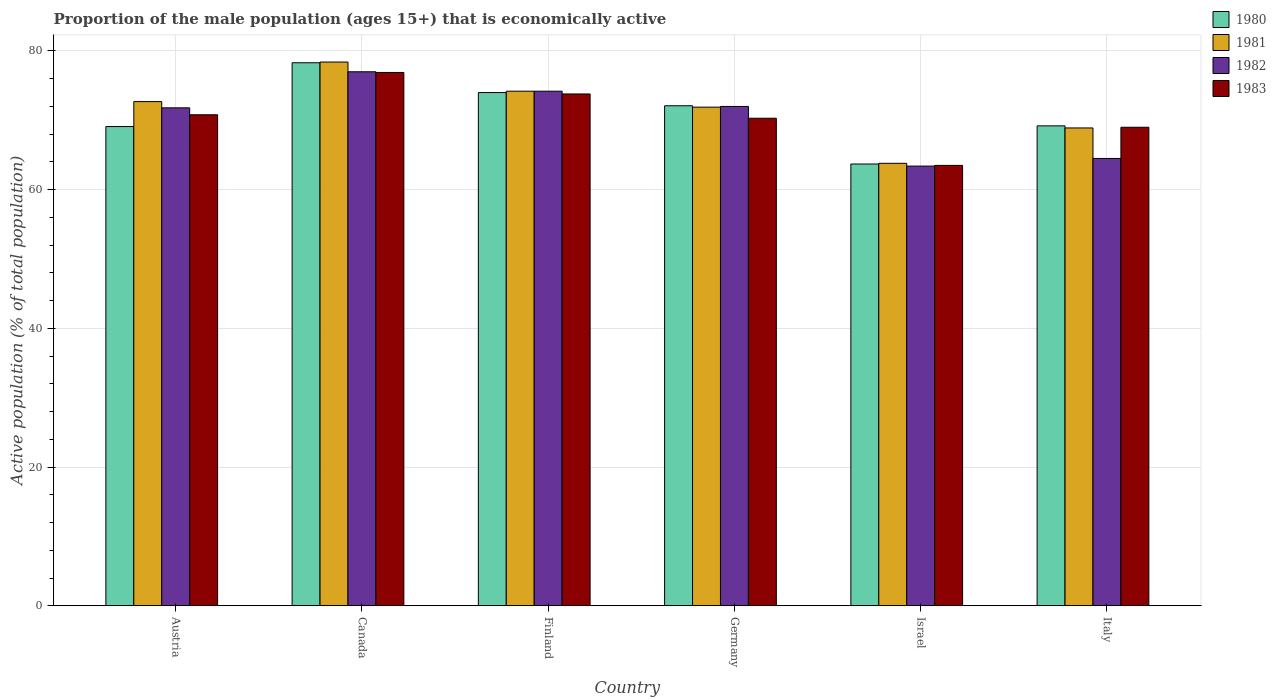How many different coloured bars are there?
Your response must be concise. 4. Are the number of bars on each tick of the X-axis equal?
Provide a succinct answer. Yes. What is the label of the 1st group of bars from the left?
Ensure brevity in your answer.  Austria. What is the proportion of the male population that is economically active in 1982 in Finland?
Keep it short and to the point. 74.2. Across all countries, what is the maximum proportion of the male population that is economically active in 1980?
Offer a very short reply. 78.3. Across all countries, what is the minimum proportion of the male population that is economically active in 1982?
Offer a terse response. 63.4. What is the total proportion of the male population that is economically active in 1982 in the graph?
Make the answer very short. 422.9. What is the difference between the proportion of the male population that is economically active in 1983 in Canada and that in Finland?
Provide a short and direct response. 3.1. What is the difference between the proportion of the male population that is economically active in 1983 in Finland and the proportion of the male population that is economically active in 1980 in Austria?
Keep it short and to the point. 4.7. What is the average proportion of the male population that is economically active in 1983 per country?
Your answer should be very brief. 70.72. What is the difference between the proportion of the male population that is economically active of/in 1983 and proportion of the male population that is economically active of/in 1980 in Austria?
Offer a terse response. 1.7. What is the ratio of the proportion of the male population that is economically active in 1981 in Austria to that in Canada?
Keep it short and to the point. 0.93. What is the difference between the highest and the second highest proportion of the male population that is economically active in 1980?
Offer a very short reply. -1.9. What is the difference between the highest and the lowest proportion of the male population that is economically active in 1981?
Ensure brevity in your answer.  14.6. In how many countries, is the proportion of the male population that is economically active in 1980 greater than the average proportion of the male population that is economically active in 1980 taken over all countries?
Your response must be concise. 3. What does the 2nd bar from the left in Canada represents?
Provide a short and direct response. 1981. Are all the bars in the graph horizontal?
Offer a terse response. No. Are the values on the major ticks of Y-axis written in scientific E-notation?
Keep it short and to the point. No. Does the graph contain any zero values?
Offer a very short reply. No. Where does the legend appear in the graph?
Make the answer very short. Top right. How are the legend labels stacked?
Offer a terse response. Vertical. What is the title of the graph?
Provide a succinct answer. Proportion of the male population (ages 15+) that is economically active. Does "1986" appear as one of the legend labels in the graph?
Your response must be concise. No. What is the label or title of the Y-axis?
Give a very brief answer. Active population (% of total population). What is the Active population (% of total population) in 1980 in Austria?
Make the answer very short. 69.1. What is the Active population (% of total population) of 1981 in Austria?
Make the answer very short. 72.7. What is the Active population (% of total population) in 1982 in Austria?
Your response must be concise. 71.8. What is the Active population (% of total population) of 1983 in Austria?
Keep it short and to the point. 70.8. What is the Active population (% of total population) in 1980 in Canada?
Provide a succinct answer. 78.3. What is the Active population (% of total population) of 1981 in Canada?
Your answer should be compact. 78.4. What is the Active population (% of total population) in 1982 in Canada?
Your response must be concise. 77. What is the Active population (% of total population) in 1983 in Canada?
Offer a terse response. 76.9. What is the Active population (% of total population) of 1980 in Finland?
Provide a succinct answer. 74. What is the Active population (% of total population) of 1981 in Finland?
Your answer should be very brief. 74.2. What is the Active population (% of total population) in 1982 in Finland?
Offer a very short reply. 74.2. What is the Active population (% of total population) in 1983 in Finland?
Provide a short and direct response. 73.8. What is the Active population (% of total population) in 1980 in Germany?
Give a very brief answer. 72.1. What is the Active population (% of total population) in 1981 in Germany?
Offer a very short reply. 71.9. What is the Active population (% of total population) of 1982 in Germany?
Give a very brief answer. 72. What is the Active population (% of total population) in 1983 in Germany?
Offer a terse response. 70.3. What is the Active population (% of total population) of 1980 in Israel?
Your answer should be compact. 63.7. What is the Active population (% of total population) in 1981 in Israel?
Offer a terse response. 63.8. What is the Active population (% of total population) in 1982 in Israel?
Offer a very short reply. 63.4. What is the Active population (% of total population) in 1983 in Israel?
Keep it short and to the point. 63.5. What is the Active population (% of total population) of 1980 in Italy?
Provide a succinct answer. 69.2. What is the Active population (% of total population) in 1981 in Italy?
Your answer should be very brief. 68.9. What is the Active population (% of total population) of 1982 in Italy?
Provide a succinct answer. 64.5. What is the Active population (% of total population) in 1983 in Italy?
Give a very brief answer. 69. Across all countries, what is the maximum Active population (% of total population) in 1980?
Offer a very short reply. 78.3. Across all countries, what is the maximum Active population (% of total population) in 1981?
Your response must be concise. 78.4. Across all countries, what is the maximum Active population (% of total population) in 1983?
Your answer should be compact. 76.9. Across all countries, what is the minimum Active population (% of total population) in 1980?
Your answer should be very brief. 63.7. Across all countries, what is the minimum Active population (% of total population) in 1981?
Give a very brief answer. 63.8. Across all countries, what is the minimum Active population (% of total population) of 1982?
Give a very brief answer. 63.4. Across all countries, what is the minimum Active population (% of total population) of 1983?
Ensure brevity in your answer.  63.5. What is the total Active population (% of total population) of 1980 in the graph?
Keep it short and to the point. 426.4. What is the total Active population (% of total population) of 1981 in the graph?
Offer a terse response. 429.9. What is the total Active population (% of total population) in 1982 in the graph?
Make the answer very short. 422.9. What is the total Active population (% of total population) of 1983 in the graph?
Ensure brevity in your answer.  424.3. What is the difference between the Active population (% of total population) of 1981 in Austria and that in Canada?
Your response must be concise. -5.7. What is the difference between the Active population (% of total population) of 1980 in Austria and that in Finland?
Your answer should be very brief. -4.9. What is the difference between the Active population (% of total population) of 1981 in Austria and that in Finland?
Ensure brevity in your answer.  -1.5. What is the difference between the Active population (% of total population) of 1982 in Austria and that in Germany?
Your answer should be compact. -0.2. What is the difference between the Active population (% of total population) of 1983 in Austria and that in Germany?
Your answer should be compact. 0.5. What is the difference between the Active population (% of total population) of 1982 in Austria and that in Israel?
Your answer should be very brief. 8.4. What is the difference between the Active population (% of total population) in 1983 in Austria and that in Israel?
Make the answer very short. 7.3. What is the difference between the Active population (% of total population) in 1981 in Austria and that in Italy?
Make the answer very short. 3.8. What is the difference between the Active population (% of total population) of 1982 in Austria and that in Italy?
Ensure brevity in your answer.  7.3. What is the difference between the Active population (% of total population) in 1980 in Canada and that in Finland?
Your answer should be compact. 4.3. What is the difference between the Active population (% of total population) of 1982 in Canada and that in Finland?
Offer a very short reply. 2.8. What is the difference between the Active population (% of total population) in 1980 in Canada and that in Germany?
Give a very brief answer. 6.2. What is the difference between the Active population (% of total population) in 1981 in Canada and that in Germany?
Your answer should be compact. 6.5. What is the difference between the Active population (% of total population) in 1983 in Canada and that in Germany?
Keep it short and to the point. 6.6. What is the difference between the Active population (% of total population) in 1980 in Canada and that in Israel?
Your answer should be very brief. 14.6. What is the difference between the Active population (% of total population) of 1981 in Canada and that in Israel?
Your response must be concise. 14.6. What is the difference between the Active population (% of total population) in 1982 in Canada and that in Israel?
Give a very brief answer. 13.6. What is the difference between the Active population (% of total population) in 1980 in Canada and that in Italy?
Offer a very short reply. 9.1. What is the difference between the Active population (% of total population) in 1981 in Canada and that in Italy?
Keep it short and to the point. 9.5. What is the difference between the Active population (% of total population) in 1982 in Canada and that in Italy?
Your response must be concise. 12.5. What is the difference between the Active population (% of total population) of 1981 in Finland and that in Germany?
Provide a succinct answer. 2.3. What is the difference between the Active population (% of total population) in 1982 in Finland and that in Germany?
Your response must be concise. 2.2. What is the difference between the Active population (% of total population) in 1982 in Finland and that in Israel?
Provide a succinct answer. 10.8. What is the difference between the Active population (% of total population) of 1983 in Finland and that in Israel?
Keep it short and to the point. 10.3. What is the difference between the Active population (% of total population) of 1980 in Finland and that in Italy?
Offer a very short reply. 4.8. What is the difference between the Active population (% of total population) of 1981 in Finland and that in Italy?
Give a very brief answer. 5.3. What is the difference between the Active population (% of total population) of 1980 in Germany and that in Italy?
Offer a very short reply. 2.9. What is the difference between the Active population (% of total population) in 1982 in Germany and that in Italy?
Give a very brief answer. 7.5. What is the difference between the Active population (% of total population) of 1983 in Germany and that in Italy?
Keep it short and to the point. 1.3. What is the difference between the Active population (% of total population) of 1980 in Israel and that in Italy?
Your response must be concise. -5.5. What is the difference between the Active population (% of total population) of 1981 in Israel and that in Italy?
Offer a very short reply. -5.1. What is the difference between the Active population (% of total population) in 1983 in Israel and that in Italy?
Make the answer very short. -5.5. What is the difference between the Active population (% of total population) in 1980 in Austria and the Active population (% of total population) in 1982 in Finland?
Your answer should be compact. -5.1. What is the difference between the Active population (% of total population) in 1981 in Austria and the Active population (% of total population) in 1983 in Finland?
Provide a succinct answer. -1.1. What is the difference between the Active population (% of total population) in 1982 in Austria and the Active population (% of total population) in 1983 in Finland?
Offer a very short reply. -2. What is the difference between the Active population (% of total population) of 1980 in Austria and the Active population (% of total population) of 1981 in Germany?
Provide a succinct answer. -2.8. What is the difference between the Active population (% of total population) of 1980 in Austria and the Active population (% of total population) of 1982 in Germany?
Provide a succinct answer. -2.9. What is the difference between the Active population (% of total population) of 1981 in Austria and the Active population (% of total population) of 1982 in Germany?
Give a very brief answer. 0.7. What is the difference between the Active population (% of total population) in 1981 in Austria and the Active population (% of total population) in 1983 in Germany?
Offer a terse response. 2.4. What is the difference between the Active population (% of total population) in 1980 in Austria and the Active population (% of total population) in 1981 in Israel?
Make the answer very short. 5.3. What is the difference between the Active population (% of total population) in 1980 in Austria and the Active population (% of total population) in 1982 in Israel?
Make the answer very short. 5.7. What is the difference between the Active population (% of total population) in 1980 in Austria and the Active population (% of total population) in 1983 in Israel?
Ensure brevity in your answer.  5.6. What is the difference between the Active population (% of total population) of 1981 in Austria and the Active population (% of total population) of 1982 in Israel?
Keep it short and to the point. 9.3. What is the difference between the Active population (% of total population) in 1981 in Austria and the Active population (% of total population) in 1983 in Israel?
Your answer should be very brief. 9.2. What is the difference between the Active population (% of total population) in 1982 in Austria and the Active population (% of total population) in 1983 in Israel?
Make the answer very short. 8.3. What is the difference between the Active population (% of total population) of 1980 in Austria and the Active population (% of total population) of 1982 in Italy?
Keep it short and to the point. 4.6. What is the difference between the Active population (% of total population) of 1981 in Austria and the Active population (% of total population) of 1982 in Italy?
Offer a terse response. 8.2. What is the difference between the Active population (% of total population) of 1980 in Canada and the Active population (% of total population) of 1983 in Finland?
Provide a succinct answer. 4.5. What is the difference between the Active population (% of total population) in 1981 in Canada and the Active population (% of total population) in 1982 in Finland?
Your response must be concise. 4.2. What is the difference between the Active population (% of total population) in 1981 in Canada and the Active population (% of total population) in 1983 in Finland?
Make the answer very short. 4.6. What is the difference between the Active population (% of total population) of 1980 in Canada and the Active population (% of total population) of 1981 in Germany?
Make the answer very short. 6.4. What is the difference between the Active population (% of total population) of 1981 in Canada and the Active population (% of total population) of 1982 in Germany?
Offer a very short reply. 6.4. What is the difference between the Active population (% of total population) in 1981 in Canada and the Active population (% of total population) in 1983 in Germany?
Keep it short and to the point. 8.1. What is the difference between the Active population (% of total population) in 1982 in Canada and the Active population (% of total population) in 1983 in Germany?
Your response must be concise. 6.7. What is the difference between the Active population (% of total population) of 1980 in Canada and the Active population (% of total population) of 1981 in Israel?
Keep it short and to the point. 14.5. What is the difference between the Active population (% of total population) of 1980 in Canada and the Active population (% of total population) of 1982 in Israel?
Ensure brevity in your answer.  14.9. What is the difference between the Active population (% of total population) in 1981 in Canada and the Active population (% of total population) in 1982 in Israel?
Make the answer very short. 15. What is the difference between the Active population (% of total population) of 1981 in Canada and the Active population (% of total population) of 1983 in Israel?
Your answer should be very brief. 14.9. What is the difference between the Active population (% of total population) in 1982 in Canada and the Active population (% of total population) in 1983 in Israel?
Your response must be concise. 13.5. What is the difference between the Active population (% of total population) in 1980 in Canada and the Active population (% of total population) in 1981 in Italy?
Provide a short and direct response. 9.4. What is the difference between the Active population (% of total population) of 1980 in Canada and the Active population (% of total population) of 1983 in Italy?
Keep it short and to the point. 9.3. What is the difference between the Active population (% of total population) in 1981 in Canada and the Active population (% of total population) in 1982 in Italy?
Keep it short and to the point. 13.9. What is the difference between the Active population (% of total population) in 1981 in Canada and the Active population (% of total population) in 1983 in Italy?
Ensure brevity in your answer.  9.4. What is the difference between the Active population (% of total population) in 1982 in Canada and the Active population (% of total population) in 1983 in Italy?
Your response must be concise. 8. What is the difference between the Active population (% of total population) of 1980 in Finland and the Active population (% of total population) of 1981 in Germany?
Provide a succinct answer. 2.1. What is the difference between the Active population (% of total population) in 1980 in Finland and the Active population (% of total population) in 1982 in Germany?
Offer a terse response. 2. What is the difference between the Active population (% of total population) of 1980 in Finland and the Active population (% of total population) of 1983 in Germany?
Offer a terse response. 3.7. What is the difference between the Active population (% of total population) of 1980 in Finland and the Active population (% of total population) of 1981 in Israel?
Give a very brief answer. 10.2. What is the difference between the Active population (% of total population) of 1980 in Finland and the Active population (% of total population) of 1983 in Israel?
Your response must be concise. 10.5. What is the difference between the Active population (% of total population) in 1982 in Finland and the Active population (% of total population) in 1983 in Israel?
Your response must be concise. 10.7. What is the difference between the Active population (% of total population) in 1980 in Finland and the Active population (% of total population) in 1982 in Italy?
Your answer should be very brief. 9.5. What is the difference between the Active population (% of total population) in 1981 in Finland and the Active population (% of total population) in 1982 in Italy?
Provide a succinct answer. 9.7. What is the difference between the Active population (% of total population) of 1980 in Germany and the Active population (% of total population) of 1981 in Israel?
Offer a terse response. 8.3. What is the difference between the Active population (% of total population) of 1980 in Germany and the Active population (% of total population) of 1982 in Israel?
Offer a terse response. 8.7. What is the difference between the Active population (% of total population) in 1980 in Germany and the Active population (% of total population) in 1983 in Israel?
Keep it short and to the point. 8.6. What is the difference between the Active population (% of total population) of 1981 in Germany and the Active population (% of total population) of 1982 in Israel?
Keep it short and to the point. 8.5. What is the difference between the Active population (% of total population) in 1981 in Germany and the Active population (% of total population) in 1983 in Israel?
Provide a succinct answer. 8.4. What is the difference between the Active population (% of total population) of 1980 in Germany and the Active population (% of total population) of 1981 in Italy?
Your response must be concise. 3.2. What is the difference between the Active population (% of total population) of 1980 in Germany and the Active population (% of total population) of 1983 in Italy?
Your answer should be very brief. 3.1. What is the difference between the Active population (% of total population) in 1981 in Germany and the Active population (% of total population) in 1982 in Italy?
Your response must be concise. 7.4. What is the difference between the Active population (% of total population) of 1982 in Germany and the Active population (% of total population) of 1983 in Italy?
Your answer should be very brief. 3. What is the difference between the Active population (% of total population) in 1980 in Israel and the Active population (% of total population) in 1981 in Italy?
Offer a terse response. -5.2. What is the difference between the Active population (% of total population) of 1980 in Israel and the Active population (% of total population) of 1983 in Italy?
Provide a short and direct response. -5.3. What is the difference between the Active population (% of total population) in 1981 in Israel and the Active population (% of total population) in 1982 in Italy?
Make the answer very short. -0.7. What is the difference between the Active population (% of total population) of 1982 in Israel and the Active population (% of total population) of 1983 in Italy?
Provide a succinct answer. -5.6. What is the average Active population (% of total population) of 1980 per country?
Give a very brief answer. 71.07. What is the average Active population (% of total population) of 1981 per country?
Your answer should be compact. 71.65. What is the average Active population (% of total population) in 1982 per country?
Give a very brief answer. 70.48. What is the average Active population (% of total population) of 1983 per country?
Ensure brevity in your answer.  70.72. What is the difference between the Active population (% of total population) of 1980 and Active population (% of total population) of 1982 in Austria?
Offer a terse response. -2.7. What is the difference between the Active population (% of total population) of 1981 and Active population (% of total population) of 1982 in Austria?
Make the answer very short. 0.9. What is the difference between the Active population (% of total population) of 1981 and Active population (% of total population) of 1983 in Austria?
Make the answer very short. 1.9. What is the difference between the Active population (% of total population) in 1980 and Active population (% of total population) in 1981 in Canada?
Provide a short and direct response. -0.1. What is the difference between the Active population (% of total population) in 1980 and Active population (% of total population) in 1982 in Canada?
Provide a succinct answer. 1.3. What is the difference between the Active population (% of total population) of 1981 and Active population (% of total population) of 1983 in Canada?
Offer a terse response. 1.5. What is the difference between the Active population (% of total population) of 1982 and Active population (% of total population) of 1983 in Canada?
Offer a terse response. 0.1. What is the difference between the Active population (% of total population) in 1980 and Active population (% of total population) in 1983 in Finland?
Your answer should be compact. 0.2. What is the difference between the Active population (% of total population) of 1982 and Active population (% of total population) of 1983 in Finland?
Offer a very short reply. 0.4. What is the difference between the Active population (% of total population) of 1980 and Active population (% of total population) of 1982 in Germany?
Your answer should be compact. 0.1. What is the difference between the Active population (% of total population) of 1981 and Active population (% of total population) of 1982 in Germany?
Your response must be concise. -0.1. What is the difference between the Active population (% of total population) of 1981 and Active population (% of total population) of 1983 in Germany?
Give a very brief answer. 1.6. What is the difference between the Active population (% of total population) of 1982 and Active population (% of total population) of 1983 in Germany?
Provide a short and direct response. 1.7. What is the difference between the Active population (% of total population) in 1980 and Active population (% of total population) in 1981 in Israel?
Ensure brevity in your answer.  -0.1. What is the difference between the Active population (% of total population) in 1980 and Active population (% of total population) in 1983 in Israel?
Offer a terse response. 0.2. What is the difference between the Active population (% of total population) in 1981 and Active population (% of total population) in 1982 in Israel?
Your response must be concise. 0.4. What is the difference between the Active population (% of total population) in 1982 and Active population (% of total population) in 1983 in Israel?
Offer a terse response. -0.1. What is the difference between the Active population (% of total population) of 1980 and Active population (% of total population) of 1981 in Italy?
Offer a terse response. 0.3. What is the difference between the Active population (% of total population) of 1980 and Active population (% of total population) of 1982 in Italy?
Provide a short and direct response. 4.7. What is the difference between the Active population (% of total population) in 1981 and Active population (% of total population) in 1982 in Italy?
Your answer should be compact. 4.4. What is the difference between the Active population (% of total population) in 1981 and Active population (% of total population) in 1983 in Italy?
Your response must be concise. -0.1. What is the ratio of the Active population (% of total population) of 1980 in Austria to that in Canada?
Ensure brevity in your answer.  0.88. What is the ratio of the Active population (% of total population) of 1981 in Austria to that in Canada?
Offer a terse response. 0.93. What is the ratio of the Active population (% of total population) in 1982 in Austria to that in Canada?
Ensure brevity in your answer.  0.93. What is the ratio of the Active population (% of total population) of 1983 in Austria to that in Canada?
Make the answer very short. 0.92. What is the ratio of the Active population (% of total population) in 1980 in Austria to that in Finland?
Your answer should be compact. 0.93. What is the ratio of the Active population (% of total population) of 1981 in Austria to that in Finland?
Your response must be concise. 0.98. What is the ratio of the Active population (% of total population) in 1983 in Austria to that in Finland?
Your answer should be very brief. 0.96. What is the ratio of the Active population (% of total population) in 1980 in Austria to that in Germany?
Keep it short and to the point. 0.96. What is the ratio of the Active population (% of total population) of 1981 in Austria to that in Germany?
Provide a succinct answer. 1.01. What is the ratio of the Active population (% of total population) of 1982 in Austria to that in Germany?
Give a very brief answer. 1. What is the ratio of the Active population (% of total population) in 1983 in Austria to that in Germany?
Offer a very short reply. 1.01. What is the ratio of the Active population (% of total population) in 1980 in Austria to that in Israel?
Keep it short and to the point. 1.08. What is the ratio of the Active population (% of total population) of 1981 in Austria to that in Israel?
Offer a terse response. 1.14. What is the ratio of the Active population (% of total population) in 1982 in Austria to that in Israel?
Provide a succinct answer. 1.13. What is the ratio of the Active population (% of total population) in 1983 in Austria to that in Israel?
Offer a terse response. 1.11. What is the ratio of the Active population (% of total population) of 1980 in Austria to that in Italy?
Provide a succinct answer. 1. What is the ratio of the Active population (% of total population) of 1981 in Austria to that in Italy?
Offer a very short reply. 1.06. What is the ratio of the Active population (% of total population) of 1982 in Austria to that in Italy?
Make the answer very short. 1.11. What is the ratio of the Active population (% of total population) of 1983 in Austria to that in Italy?
Keep it short and to the point. 1.03. What is the ratio of the Active population (% of total population) of 1980 in Canada to that in Finland?
Give a very brief answer. 1.06. What is the ratio of the Active population (% of total population) of 1981 in Canada to that in Finland?
Your answer should be compact. 1.06. What is the ratio of the Active population (% of total population) of 1982 in Canada to that in Finland?
Provide a short and direct response. 1.04. What is the ratio of the Active population (% of total population) of 1983 in Canada to that in Finland?
Ensure brevity in your answer.  1.04. What is the ratio of the Active population (% of total population) of 1980 in Canada to that in Germany?
Give a very brief answer. 1.09. What is the ratio of the Active population (% of total population) of 1981 in Canada to that in Germany?
Ensure brevity in your answer.  1.09. What is the ratio of the Active population (% of total population) of 1982 in Canada to that in Germany?
Your answer should be compact. 1.07. What is the ratio of the Active population (% of total population) in 1983 in Canada to that in Germany?
Your answer should be compact. 1.09. What is the ratio of the Active population (% of total population) of 1980 in Canada to that in Israel?
Your response must be concise. 1.23. What is the ratio of the Active population (% of total population) of 1981 in Canada to that in Israel?
Your answer should be compact. 1.23. What is the ratio of the Active population (% of total population) of 1982 in Canada to that in Israel?
Make the answer very short. 1.21. What is the ratio of the Active population (% of total population) of 1983 in Canada to that in Israel?
Provide a succinct answer. 1.21. What is the ratio of the Active population (% of total population) of 1980 in Canada to that in Italy?
Offer a terse response. 1.13. What is the ratio of the Active population (% of total population) of 1981 in Canada to that in Italy?
Your answer should be compact. 1.14. What is the ratio of the Active population (% of total population) of 1982 in Canada to that in Italy?
Provide a short and direct response. 1.19. What is the ratio of the Active population (% of total population) of 1983 in Canada to that in Italy?
Offer a very short reply. 1.11. What is the ratio of the Active population (% of total population) of 1980 in Finland to that in Germany?
Keep it short and to the point. 1.03. What is the ratio of the Active population (% of total population) of 1981 in Finland to that in Germany?
Keep it short and to the point. 1.03. What is the ratio of the Active population (% of total population) of 1982 in Finland to that in Germany?
Offer a very short reply. 1.03. What is the ratio of the Active population (% of total population) in 1983 in Finland to that in Germany?
Offer a terse response. 1.05. What is the ratio of the Active population (% of total population) of 1980 in Finland to that in Israel?
Provide a short and direct response. 1.16. What is the ratio of the Active population (% of total population) in 1981 in Finland to that in Israel?
Offer a very short reply. 1.16. What is the ratio of the Active population (% of total population) of 1982 in Finland to that in Israel?
Provide a short and direct response. 1.17. What is the ratio of the Active population (% of total population) in 1983 in Finland to that in Israel?
Offer a very short reply. 1.16. What is the ratio of the Active population (% of total population) in 1980 in Finland to that in Italy?
Offer a very short reply. 1.07. What is the ratio of the Active population (% of total population) in 1982 in Finland to that in Italy?
Your response must be concise. 1.15. What is the ratio of the Active population (% of total population) in 1983 in Finland to that in Italy?
Offer a terse response. 1.07. What is the ratio of the Active population (% of total population) of 1980 in Germany to that in Israel?
Offer a terse response. 1.13. What is the ratio of the Active population (% of total population) in 1981 in Germany to that in Israel?
Keep it short and to the point. 1.13. What is the ratio of the Active population (% of total population) in 1982 in Germany to that in Israel?
Make the answer very short. 1.14. What is the ratio of the Active population (% of total population) in 1983 in Germany to that in Israel?
Give a very brief answer. 1.11. What is the ratio of the Active population (% of total population) of 1980 in Germany to that in Italy?
Provide a short and direct response. 1.04. What is the ratio of the Active population (% of total population) of 1981 in Germany to that in Italy?
Make the answer very short. 1.04. What is the ratio of the Active population (% of total population) in 1982 in Germany to that in Italy?
Your answer should be compact. 1.12. What is the ratio of the Active population (% of total population) of 1983 in Germany to that in Italy?
Your answer should be very brief. 1.02. What is the ratio of the Active population (% of total population) in 1980 in Israel to that in Italy?
Your response must be concise. 0.92. What is the ratio of the Active population (% of total population) of 1981 in Israel to that in Italy?
Ensure brevity in your answer.  0.93. What is the ratio of the Active population (% of total population) in 1982 in Israel to that in Italy?
Your response must be concise. 0.98. What is the ratio of the Active population (% of total population) in 1983 in Israel to that in Italy?
Offer a very short reply. 0.92. What is the difference between the highest and the second highest Active population (% of total population) of 1982?
Provide a short and direct response. 2.8. What is the difference between the highest and the lowest Active population (% of total population) of 1983?
Your answer should be very brief. 13.4. 